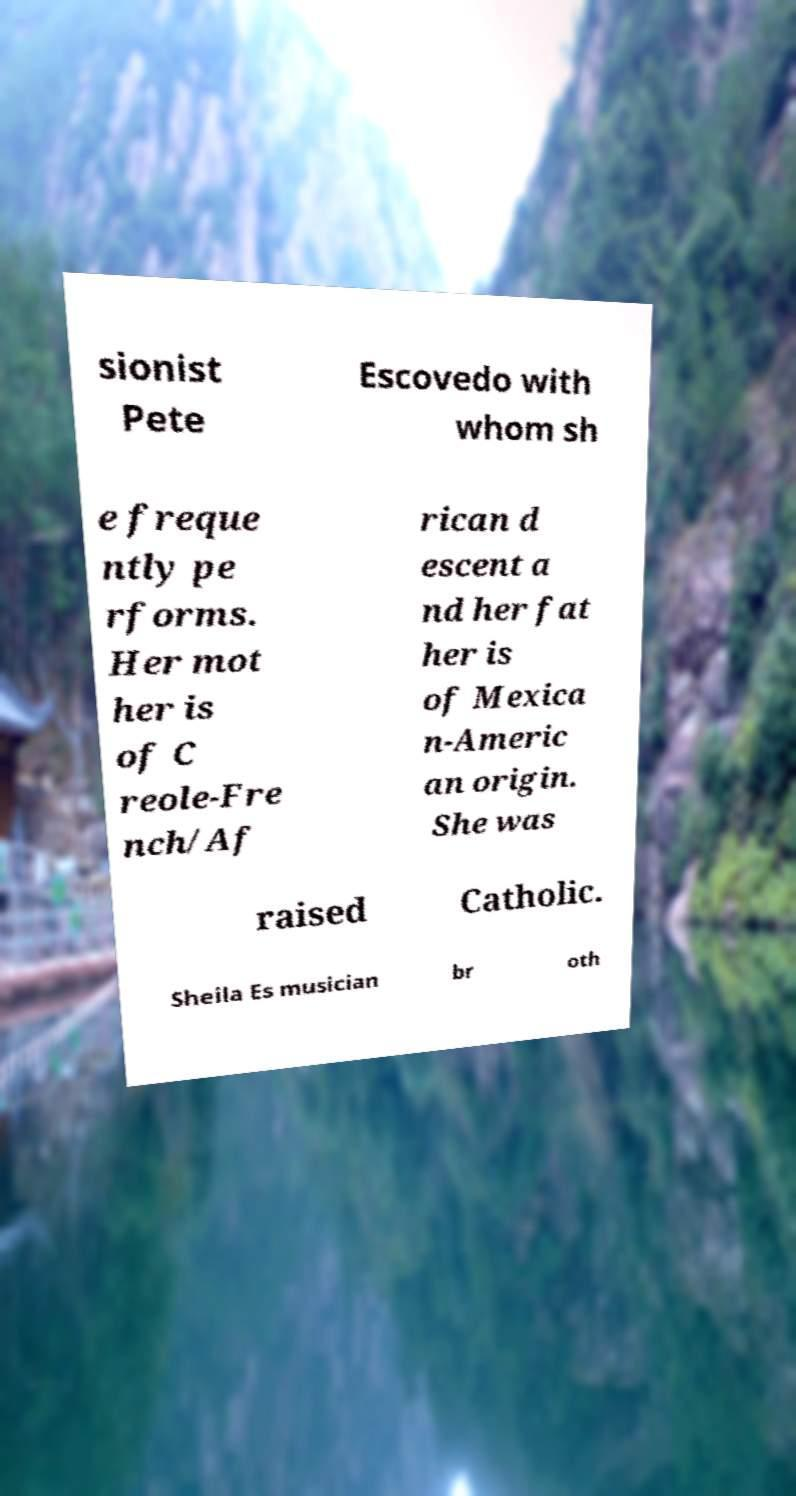What messages or text are displayed in this image? I need them in a readable, typed format. sionist Pete Escovedo with whom sh e freque ntly pe rforms. Her mot her is of C reole-Fre nch/Af rican d escent a nd her fat her is of Mexica n-Americ an origin. She was raised Catholic. Sheila Es musician br oth 